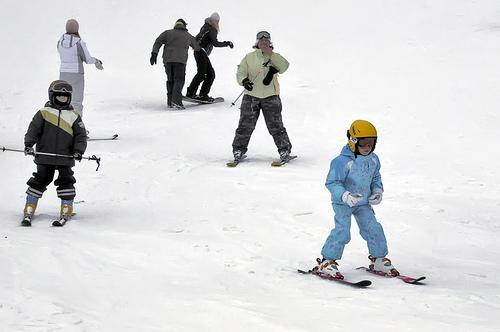What is the likely relationship of the woman to the kids? mother 